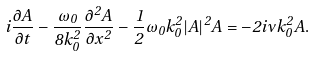<formula> <loc_0><loc_0><loc_500><loc_500>i \frac { \partial A } { \partial t } - \frac { \omega _ { 0 } } { 8 k _ { 0 } ^ { 2 } } \frac { \partial ^ { 2 } A } { \partial x ^ { 2 } } - \frac { 1 } { 2 } \omega _ { 0 } k _ { 0 } ^ { 2 } | A | ^ { 2 } A = - 2 i \nu k _ { 0 } ^ { 2 } A .</formula> 